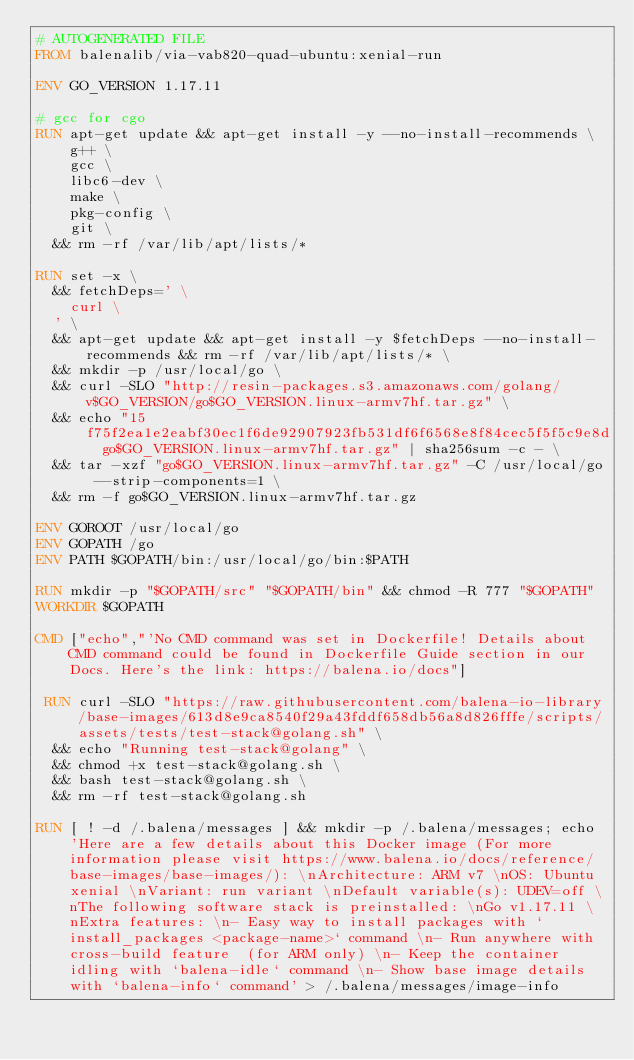Convert code to text. <code><loc_0><loc_0><loc_500><loc_500><_Dockerfile_># AUTOGENERATED FILE
FROM balenalib/via-vab820-quad-ubuntu:xenial-run

ENV GO_VERSION 1.17.11

# gcc for cgo
RUN apt-get update && apt-get install -y --no-install-recommends \
		g++ \
		gcc \
		libc6-dev \
		make \
		pkg-config \
		git \
	&& rm -rf /var/lib/apt/lists/*

RUN set -x \
	&& fetchDeps=' \
		curl \
	' \
	&& apt-get update && apt-get install -y $fetchDeps --no-install-recommends && rm -rf /var/lib/apt/lists/* \
	&& mkdir -p /usr/local/go \
	&& curl -SLO "http://resin-packages.s3.amazonaws.com/golang/v$GO_VERSION/go$GO_VERSION.linux-armv7hf.tar.gz" \
	&& echo "15f75f2ea1e2eabf30ec1f6de92907923fb531df6f6568e8f84cec5f5f5c9e8d  go$GO_VERSION.linux-armv7hf.tar.gz" | sha256sum -c - \
	&& tar -xzf "go$GO_VERSION.linux-armv7hf.tar.gz" -C /usr/local/go --strip-components=1 \
	&& rm -f go$GO_VERSION.linux-armv7hf.tar.gz

ENV GOROOT /usr/local/go
ENV GOPATH /go
ENV PATH $GOPATH/bin:/usr/local/go/bin:$PATH

RUN mkdir -p "$GOPATH/src" "$GOPATH/bin" && chmod -R 777 "$GOPATH"
WORKDIR $GOPATH

CMD ["echo","'No CMD command was set in Dockerfile! Details about CMD command could be found in Dockerfile Guide section in our Docs. Here's the link: https://balena.io/docs"]

 RUN curl -SLO "https://raw.githubusercontent.com/balena-io-library/base-images/613d8e9ca8540f29a43fddf658db56a8d826fffe/scripts/assets/tests/test-stack@golang.sh" \
  && echo "Running test-stack@golang" \
  && chmod +x test-stack@golang.sh \
  && bash test-stack@golang.sh \
  && rm -rf test-stack@golang.sh 

RUN [ ! -d /.balena/messages ] && mkdir -p /.balena/messages; echo 'Here are a few details about this Docker image (For more information please visit https://www.balena.io/docs/reference/base-images/base-images/): \nArchitecture: ARM v7 \nOS: Ubuntu xenial \nVariant: run variant \nDefault variable(s): UDEV=off \nThe following software stack is preinstalled: \nGo v1.17.11 \nExtra features: \n- Easy way to install packages with `install_packages <package-name>` command \n- Run anywhere with cross-build feature  (for ARM only) \n- Keep the container idling with `balena-idle` command \n- Show base image details with `balena-info` command' > /.balena/messages/image-info</code> 